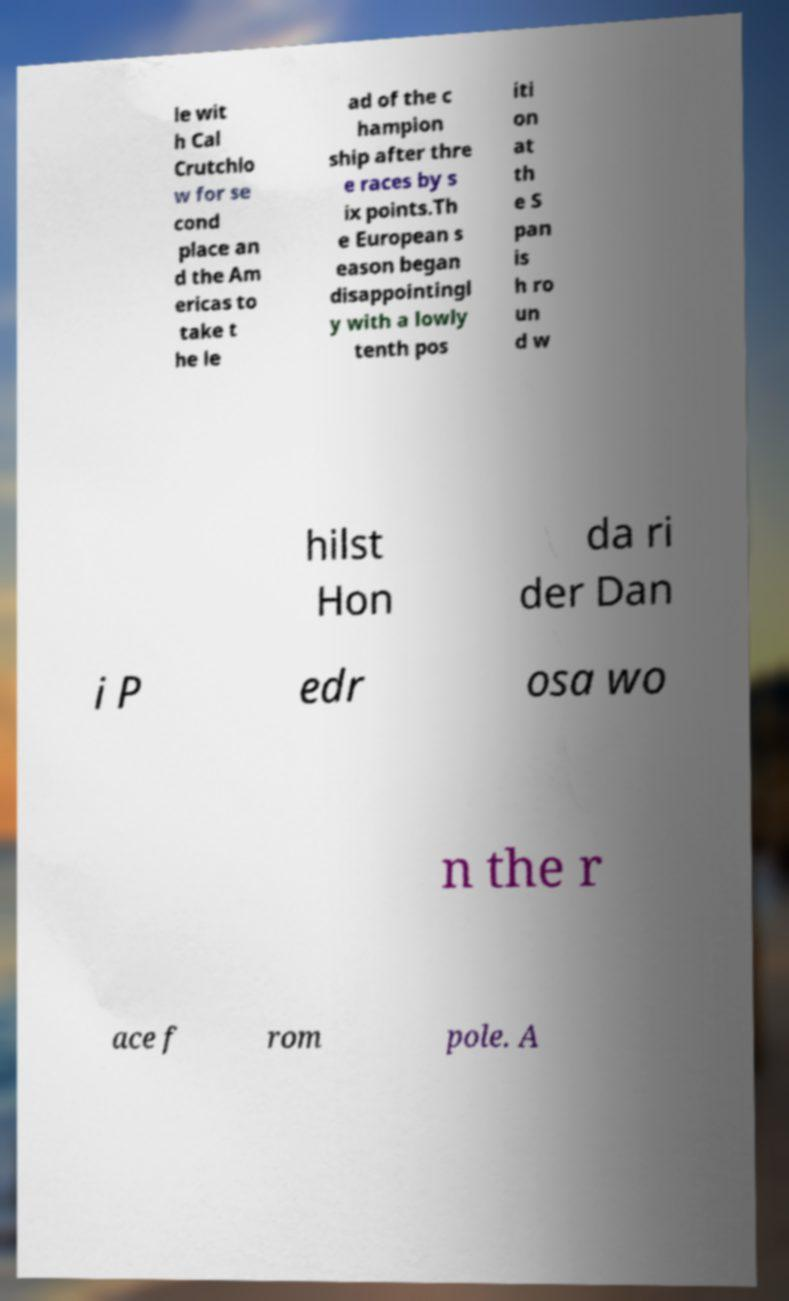Could you extract and type out the text from this image? le wit h Cal Crutchlo w for se cond place an d the Am ericas to take t he le ad of the c hampion ship after thre e races by s ix points.Th e European s eason began disappointingl y with a lowly tenth pos iti on at th e S pan is h ro un d w hilst Hon da ri der Dan i P edr osa wo n the r ace f rom pole. A 